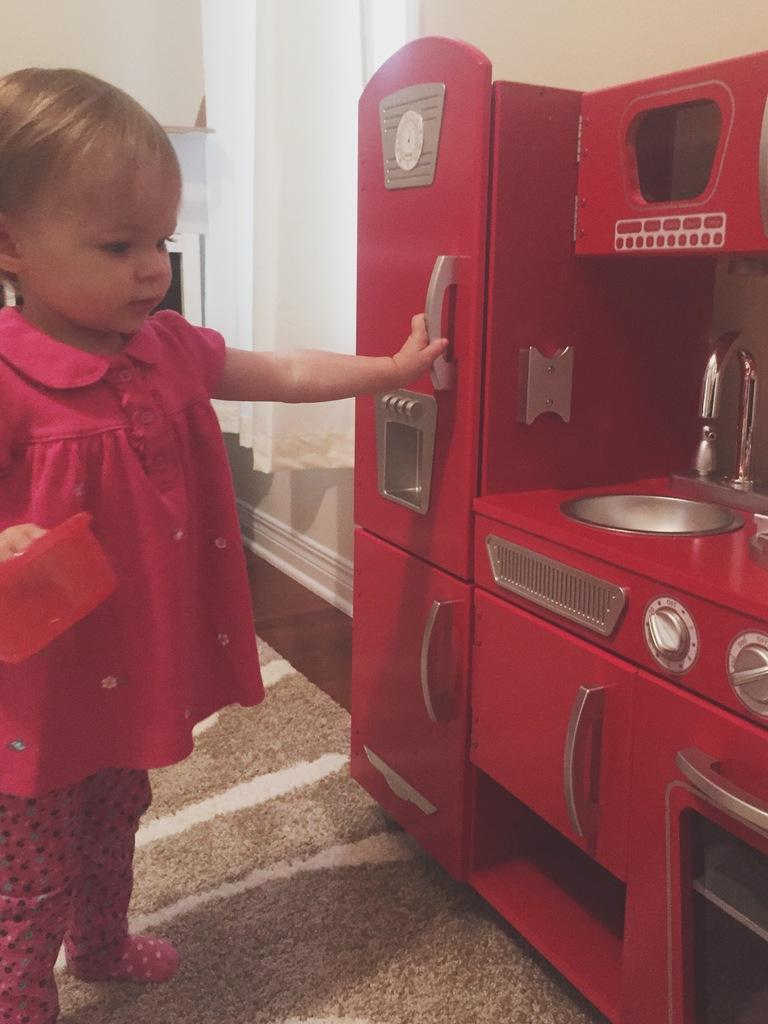Who is the main subject in the image? There is a girl in the image. Where is the girl located in the image? The girl is on the left side. What is the girl holding in the image? The girl is holding a bowl. What type of structure can be seen in the background of the image? There is a wall in the image. What appliance is present in the image? There is a refrigerator in the image. What type of furniture is present in the image? There is a kitchen cabinet in the image. What degree does the girl have in the image? There is no indication of the girl's educational background or degree in the image. Can you see a ball in the image? There is no ball present in the image. 